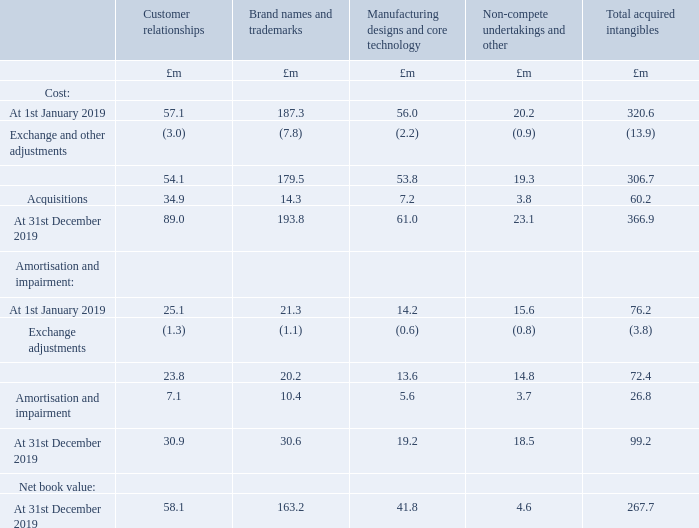15 Goodwill and other intangible assets continued
Acquired intangibles
The disclosure by class of acquired intangible assets is shown in the tables below.
2019
Customer relationships are amortised over their useful economic lives in line with the accounting policies disclosed in Note 1. Within this balance individually material balances relate to Thermocoax £32.6m. The remaining amortisation period is 14.3 years.
Brand names and trademark assets are amortised over their useful economic lives in line with the accounting policies disclosed in Note 1. Within this balance individually material balances relate to Chromalox £114.1m (2018: £125.4m), Gestra £28.4m (2018: £32.5m) and Thermocoax £13.6m. The remaining amortisation periods are 17.5 years, 12.3 years and 19.3 years respectively.
Manufacturing designs and core technology are amortised over their useful economic lives in line with the accounting policies disclosed in Note 1. Within this balance individually material balances relate to Chromalox £12.9m (2018: £15.1m), Gestra £10.8m (2018: £12.3m) and Aflex £8.5m (2018: £9.4m). The remaining amortisation period is 12.5 years for Chromalox, 12.3 years for Gestra and 10 years for Aflex.
Non-compete undertakings are amortised over their useful economic lives in line with the accounting policies disclosed in Note 1. There are no individually material items within this balance.
How are non-complete undertakings amortised? Amortised over their useful economic lives in line with the accounting policies disclosed in note 1. What do the individually material balances within the balance of brand names and trademark assets after amortisation relate to? Chromalox, gestra, thermocoax. What are the different classes of acquired intangible assets in the table? Customer relationships, brand names and trademarks, manufacturing designs and core technology, non-compete undertakings and other. Which class of acquired intangible assets shown in the table has the lowest amount of acquisitions? 3.8<7.2<14.3<34.9
Answer: non-compete undertakings and other. What was the change in the amount of individually material balances under manufacturing designs and core technology for Aflex in 2019 from 2018?
Answer scale should be: million. 8.5-9.4
Answer: -0.9. What was the percentage change in the amount of individually material balances under manufacturing designs and core technology for Aflex in 2019 from 2018?
Answer scale should be: percent. (8.5-9.4)/9.4
Answer: -9.57. 